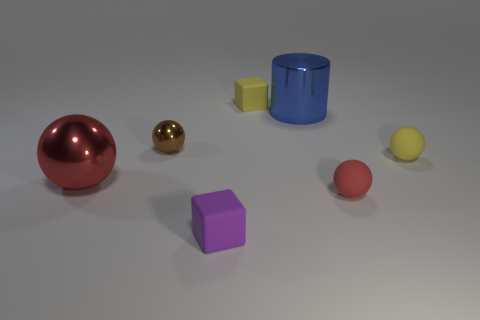Add 3 large metal balls. How many objects exist? 10 Subtract all blocks. How many objects are left? 5 Subtract 0 purple cylinders. How many objects are left? 7 Subtract all tiny brown rubber cubes. Subtract all big cylinders. How many objects are left? 6 Add 2 small yellow things. How many small yellow things are left? 4 Add 5 small yellow spheres. How many small yellow spheres exist? 6 